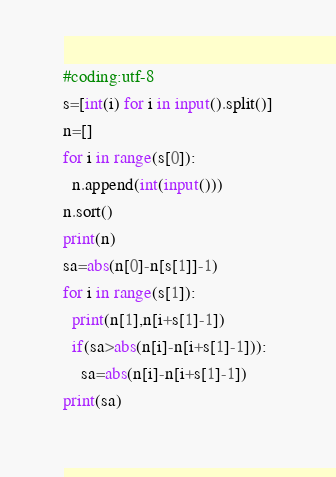Convert code to text. <code><loc_0><loc_0><loc_500><loc_500><_Python_>#coding:utf-8
s=[int(i) for i in input().split()]
n=[]
for i in range(s[0]):
  n.append(int(input()))
n.sort()
print(n)
sa=abs(n[0]-n[s[1]]-1)
for i in range(s[1]):
  print(n[1],n[i+s[1]-1])
  if(sa>abs(n[i]-n[i+s[1]-1])):
    sa=abs(n[i]-n[i+s[1]-1])
print(sa)</code> 